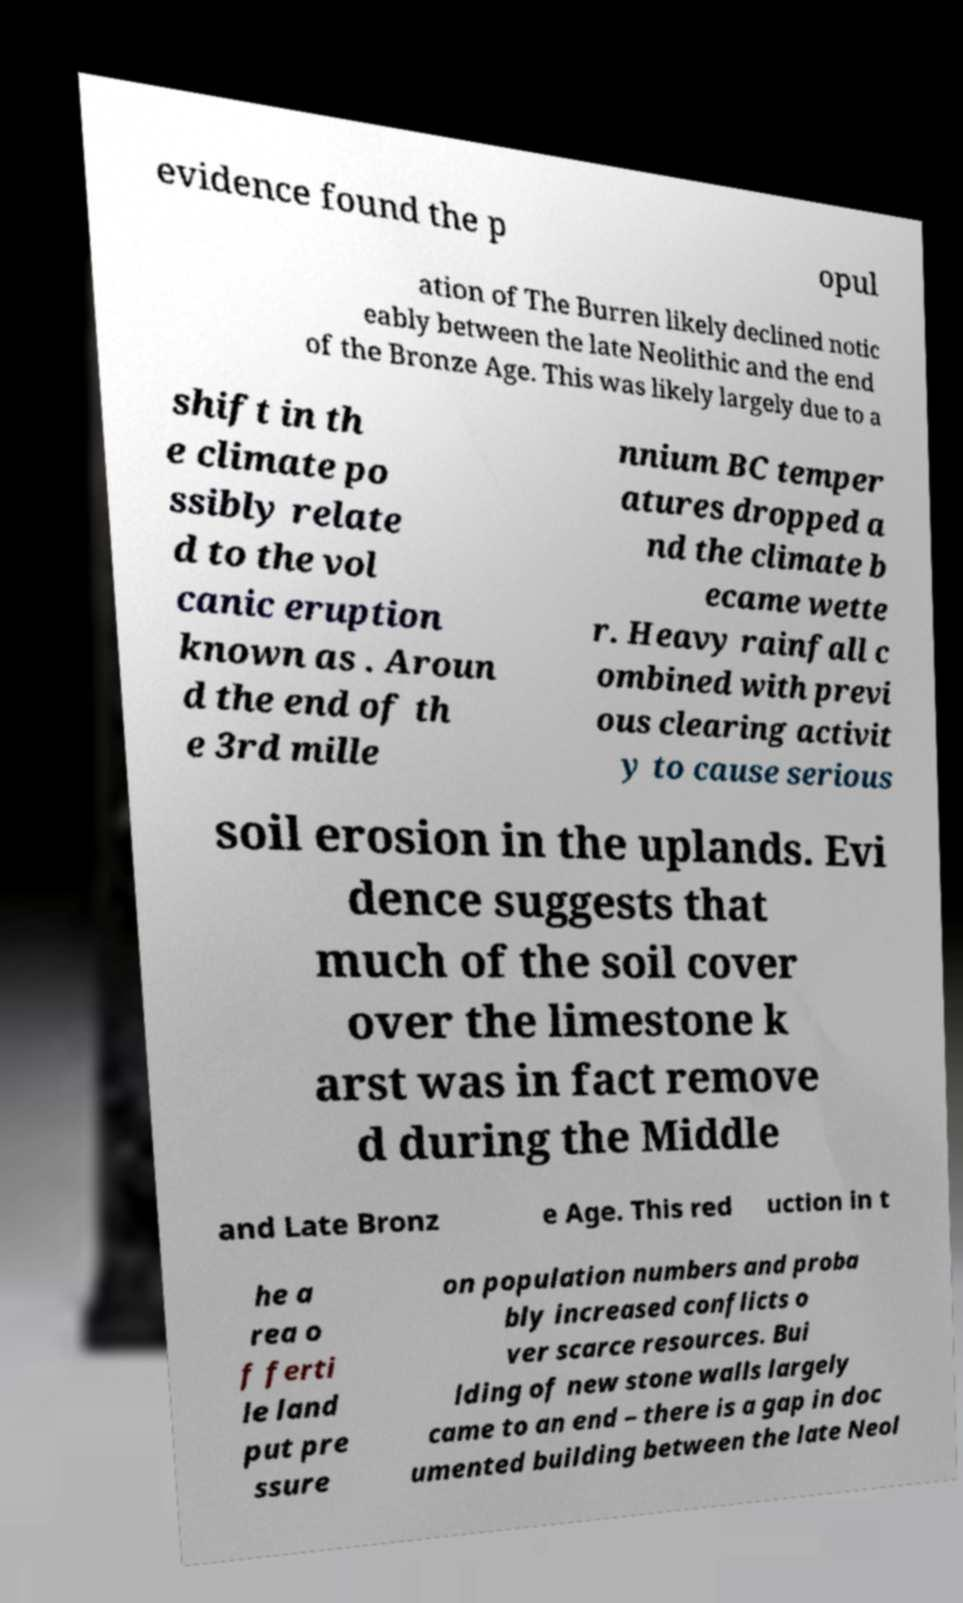Please read and relay the text visible in this image. What does it say? evidence found the p opul ation of The Burren likely declined notic eably between the late Neolithic and the end of the Bronze Age. This was likely largely due to a shift in th e climate po ssibly relate d to the vol canic eruption known as . Aroun d the end of th e 3rd mille nnium BC temper atures dropped a nd the climate b ecame wette r. Heavy rainfall c ombined with previ ous clearing activit y to cause serious soil erosion in the uplands. Evi dence suggests that much of the soil cover over the limestone k arst was in fact remove d during the Middle and Late Bronz e Age. This red uction in t he a rea o f ferti le land put pre ssure on population numbers and proba bly increased conflicts o ver scarce resources. Bui lding of new stone walls largely came to an end – there is a gap in doc umented building between the late Neol 